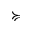<formula> <loc_0><loc_0><loc_500><loc_500>\succ c u r l y e q</formula> 